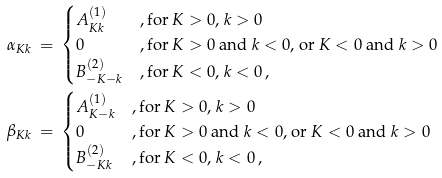<formula> <loc_0><loc_0><loc_500><loc_500>\alpha _ { K k } \, & = \, \begin{cases} A _ { K k } ^ { ( 1 ) } & , \text {for $K>0$, $k>0$} \\ 0 & , \text {for $K>0$ and $k<0$, or $K<0$ and $k>0$} \\ B _ { - K - k } ^ { ( 2 ) } & , \text {for $K<0$, $k<0$} \, , \end{cases} \\ \beta _ { K k } \, & = \, \begin{cases} A _ { K - k } ^ { ( 1 ) } & , \text {for $K>0$, $k>0$} \\ 0 & , \text {for $K>0$ and $k<0$, or $K<0$ and $k>0$} \\ B _ { - K k } ^ { ( 2 ) } & , \text {for $K<0$, $k<0$} \, , \end{cases}</formula> 